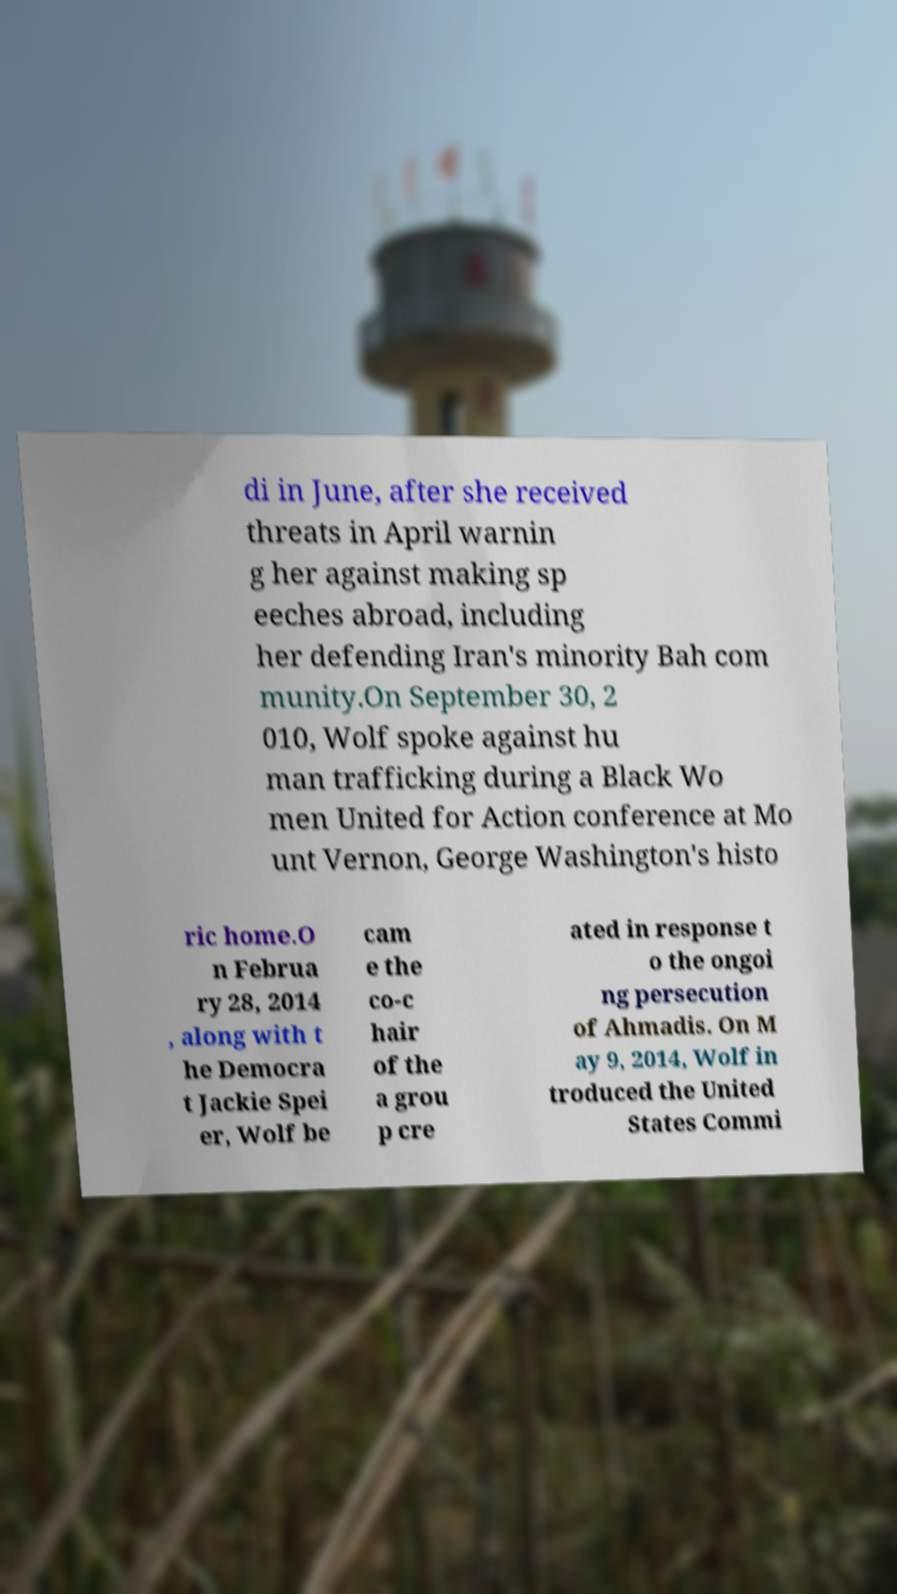Please identify and transcribe the text found in this image. di in June, after she received threats in April warnin g her against making sp eeches abroad, including her defending Iran's minority Bah com munity.On September 30, 2 010, Wolf spoke against hu man trafficking during a Black Wo men United for Action conference at Mo unt Vernon, George Washington's histo ric home.O n Februa ry 28, 2014 , along with t he Democra t Jackie Spei er, Wolf be cam e the co-c hair of the a grou p cre ated in response t o the ongoi ng persecution of Ahmadis. On M ay 9, 2014, Wolf in troduced the United States Commi 